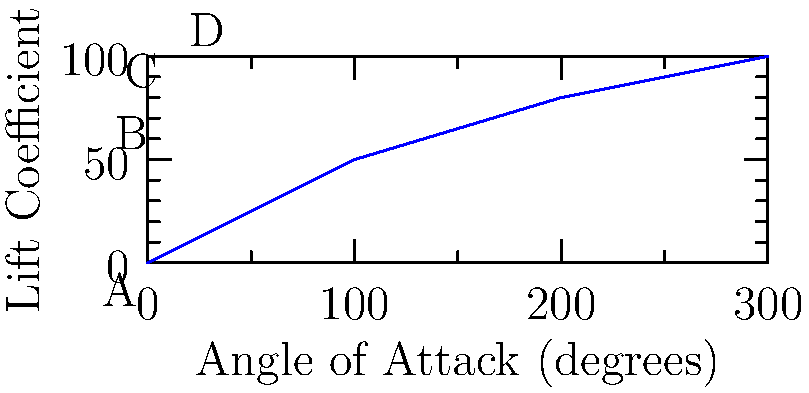The graph shows the relationship between the angle of attack and lift coefficient for an airfoil. At which point does the airfoil likely experience flow separation, potentially leading to stall? To answer this question, we need to understand the relationship between angle of attack, lift coefficient, and flow separation:

1. As the angle of attack increases, the lift coefficient generally increases up to a certain point.

2. The graph shows four points (A, B, C, and D) corresponding to different angles of attack.

3. From A to C, we see a steady increase in lift coefficient as the angle of attack increases. This is the normal operating range for the airfoil.

4. Between C and D, we notice that the rate of increase in lift coefficient slows down significantly.

5. This sudden change in the slope of the curve typically indicates the onset of flow separation.

6. Flow separation occurs when the airflow can no longer follow the upper surface of the airfoil, leading to a loss of lift and potentially causing stall.

7. Point D, at the highest angle of attack (15 degrees), is where the flow is most likely to separate from the airfoil surface.

Therefore, point D is where the airfoil likely experiences flow separation, potentially leading to stall.
Answer: Point D (15 degrees angle of attack) 